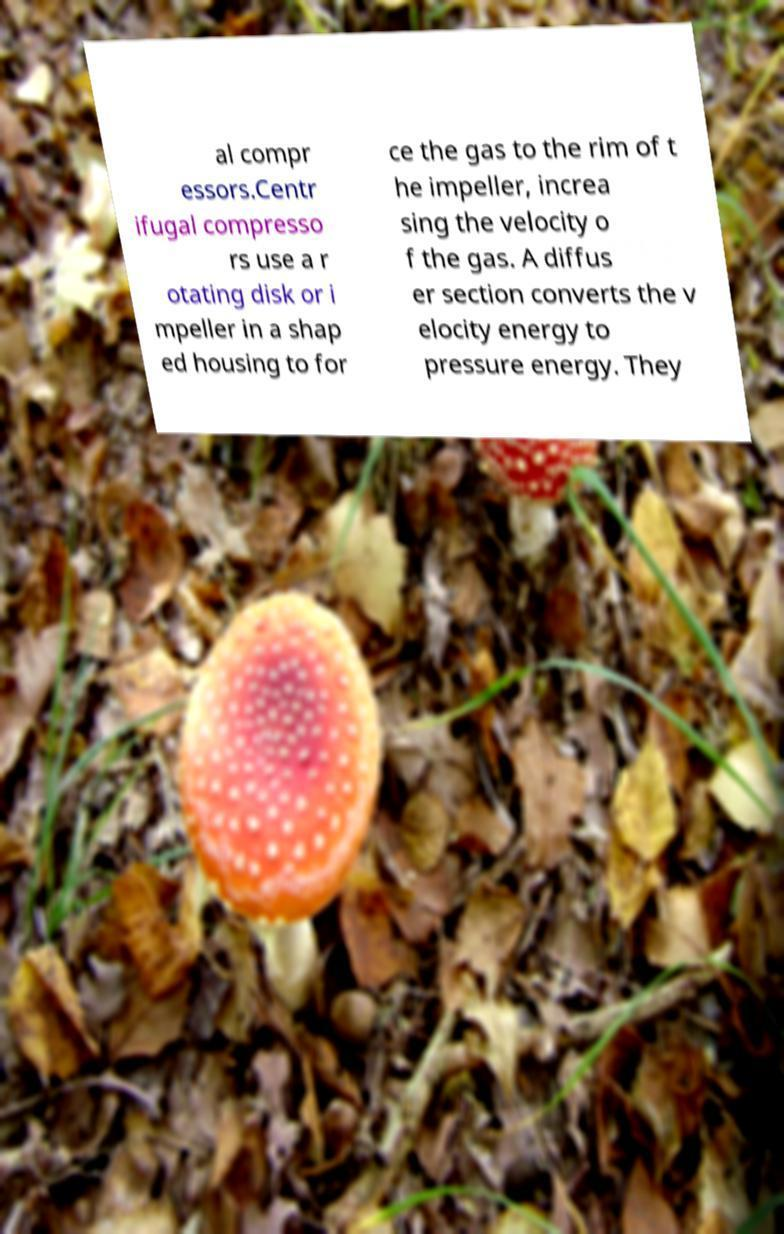For documentation purposes, I need the text within this image transcribed. Could you provide that? al compr essors.Centr ifugal compresso rs use a r otating disk or i mpeller in a shap ed housing to for ce the gas to the rim of t he impeller, increa sing the velocity o f the gas. A diffus er section converts the v elocity energy to pressure energy. They 